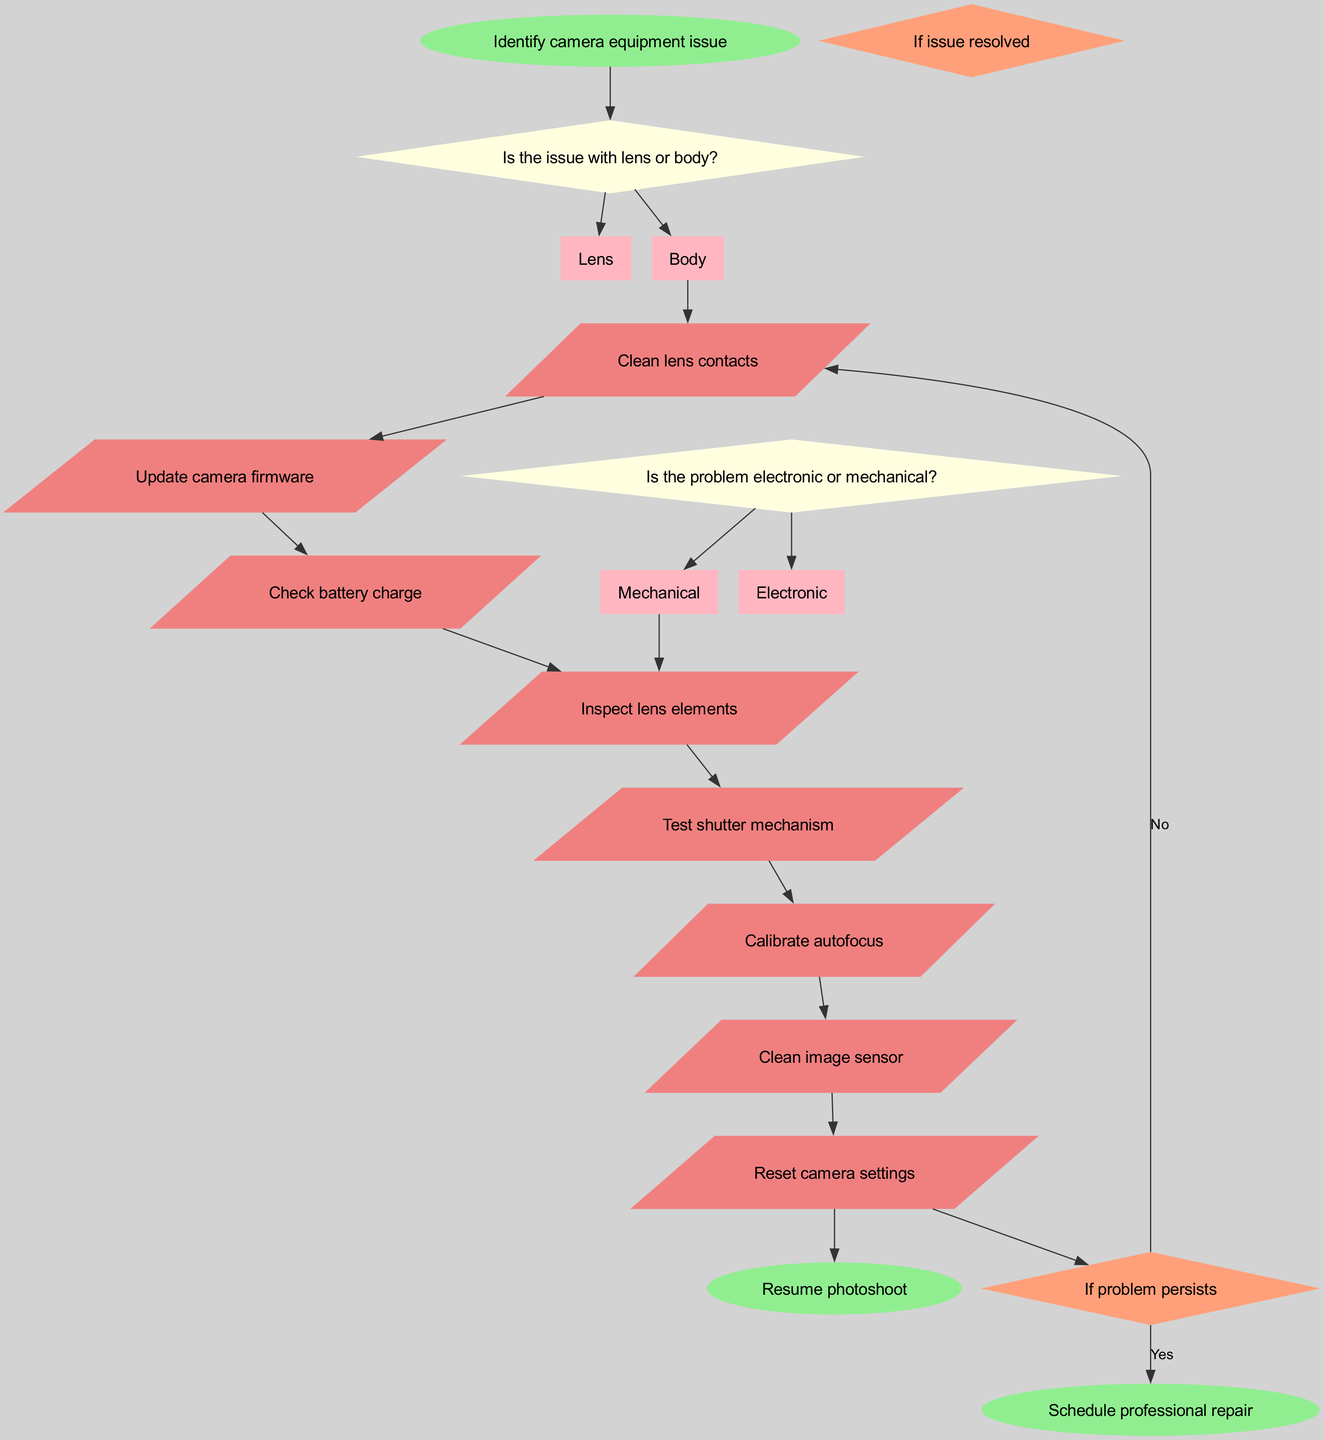What is the starting point of the flowchart? The flowchart begins with the node labeled "Identify camera equipment issue." This is the first node that directs the troubleshooting process.
Answer: Identify camera equipment issue How many decision nodes are present in the diagram? There are two decision nodes in the diagram: one asks about the lens or body, and the other about electronic or mechanical problems.
Answer: 2 If the issue is with the body, what is the next action to check? After confirming the issue with the body, the next action taken in the flow is to check the battery charge, which leads to potential actions related to electronic problems.
Answer: Check battery charge What action is taken if an electronic problem is confirmed? If the problem is confirmed to be electronic, the action taken is to update the camera firmware, as indicated in the flow of actions related to electronic issues.
Answer: Update camera firmware What happens if the problem persists after cleaning the image sensor? If the problem persists after cleaning the image sensor, the flow leads to scheduling a professional repair as indicated by the connection from the conditional node.
Answer: Schedule professional repair If the issue is resolved after the initial troubleshooting steps, what should the photographer do next? If the troubleshooting steps resolve the issue, the next step for the photographer is to resume the photoshoot, as shown in the flow’s end state.
Answer: Resume photoshoot What are the colors used for action nodes in the diagram? Action nodes are displayed in light coral color according to the attributes outlined in the flowchart generation code.
Answer: Light coral Which node connects the actions to the end states? The conditional node labeled "If problem persists" connects the actions to the end states, allowing the flow to diverge based on the outcome of prior actions.
Answer: If problem persists 